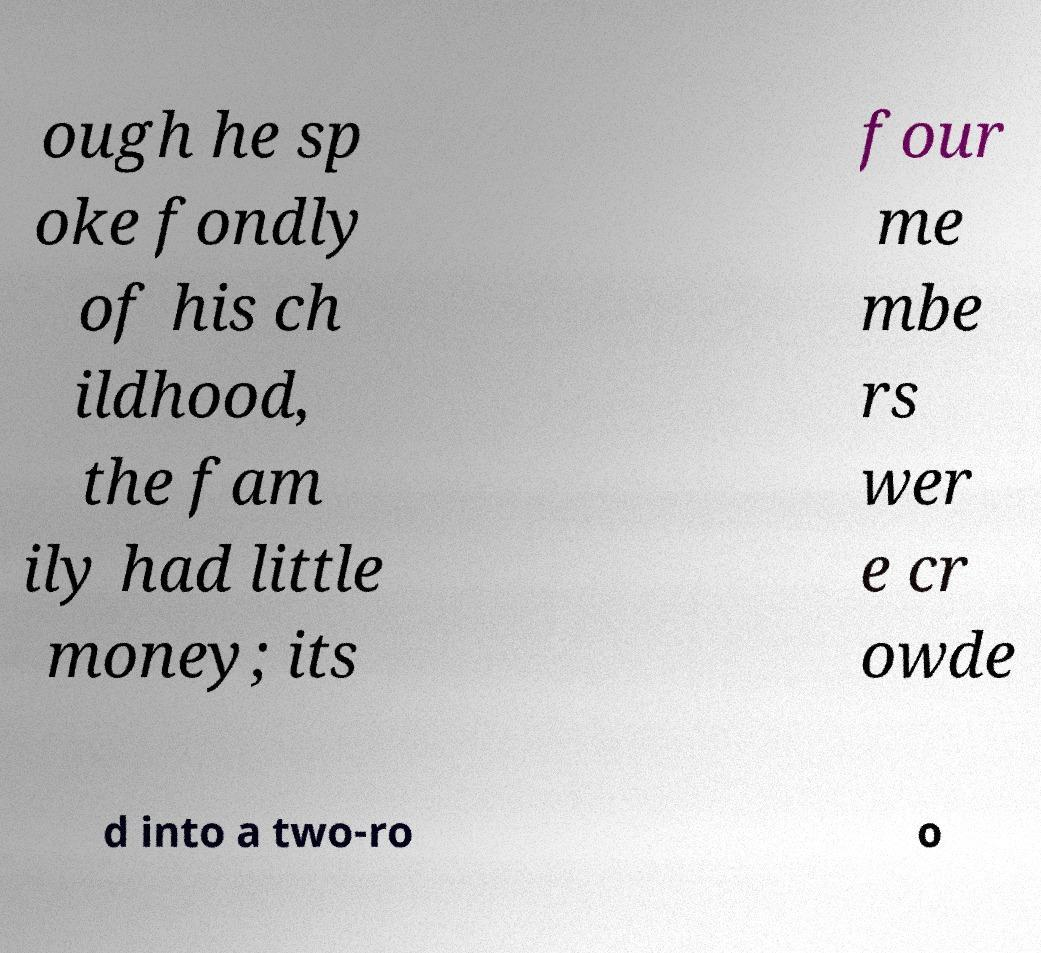Can you read and provide the text displayed in the image?This photo seems to have some interesting text. Can you extract and type it out for me? ough he sp oke fondly of his ch ildhood, the fam ily had little money; its four me mbe rs wer e cr owde d into a two-ro o 